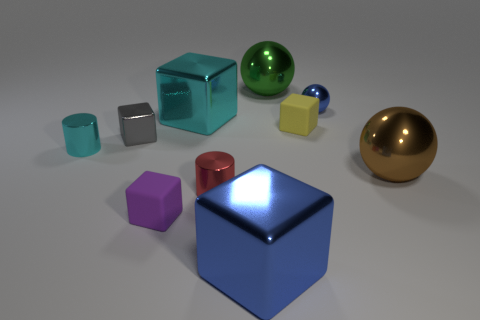Subtract all large cyan metallic cubes. How many cubes are left? 4 Subtract all yellow cubes. How many cubes are left? 4 Subtract all green blocks. Subtract all red balls. How many blocks are left? 5 Subtract all cylinders. How many objects are left? 8 Subtract all yellow rubber things. Subtract all tiny yellow matte objects. How many objects are left? 8 Add 9 small cyan objects. How many small cyan objects are left? 10 Add 7 big green metal cubes. How many big green metal cubes exist? 7 Subtract 0 gray cylinders. How many objects are left? 10 